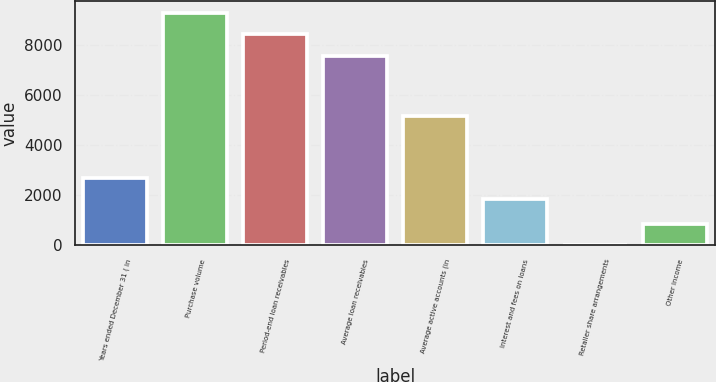Convert chart. <chart><loc_0><loc_0><loc_500><loc_500><bar_chart><fcel>Years ended December 31 ( in<fcel>Purchase volume<fcel>Period-end loan receivables<fcel>Average loan receivables<fcel>Average active accounts (in<fcel>Interest and fees on loans<fcel>Retailer share arrangements<fcel>Other income<nl><fcel>2689.9<fcel>9291.8<fcel>8433.9<fcel>7576<fcel>5174<fcel>1832<fcel>6<fcel>863.9<nl></chart> 